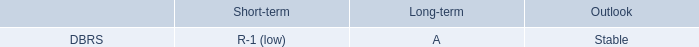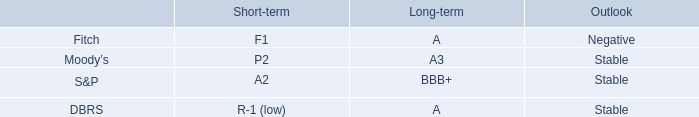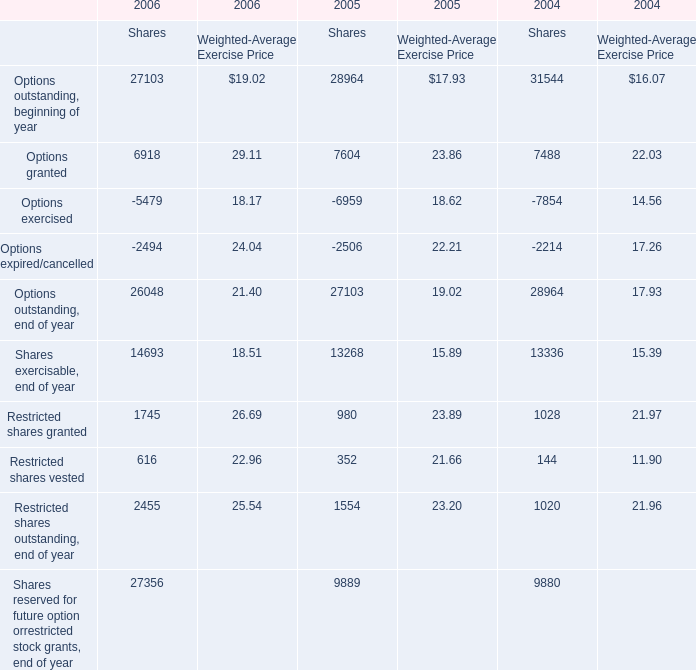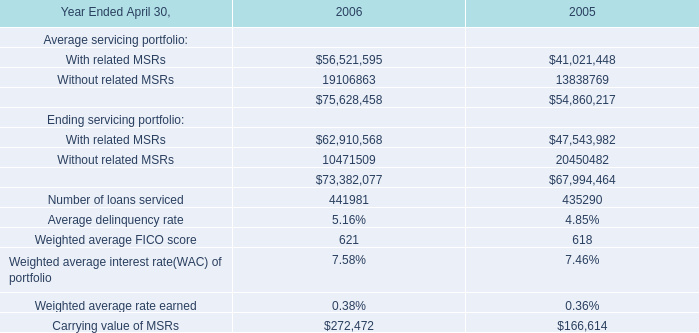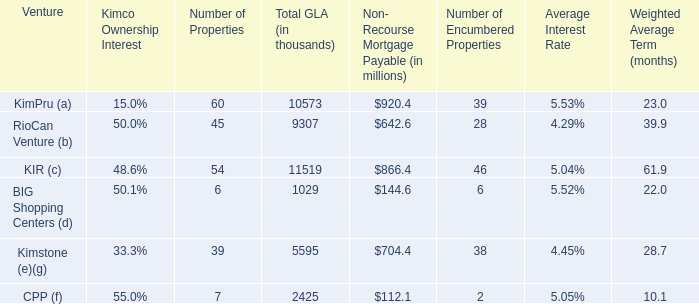as of december 31 , 2014 , what was the proportionate share of the company 2019s unconsolidated real estate joint ventures . 
Computations: (1.8 / 4.6)
Answer: 0.3913. 